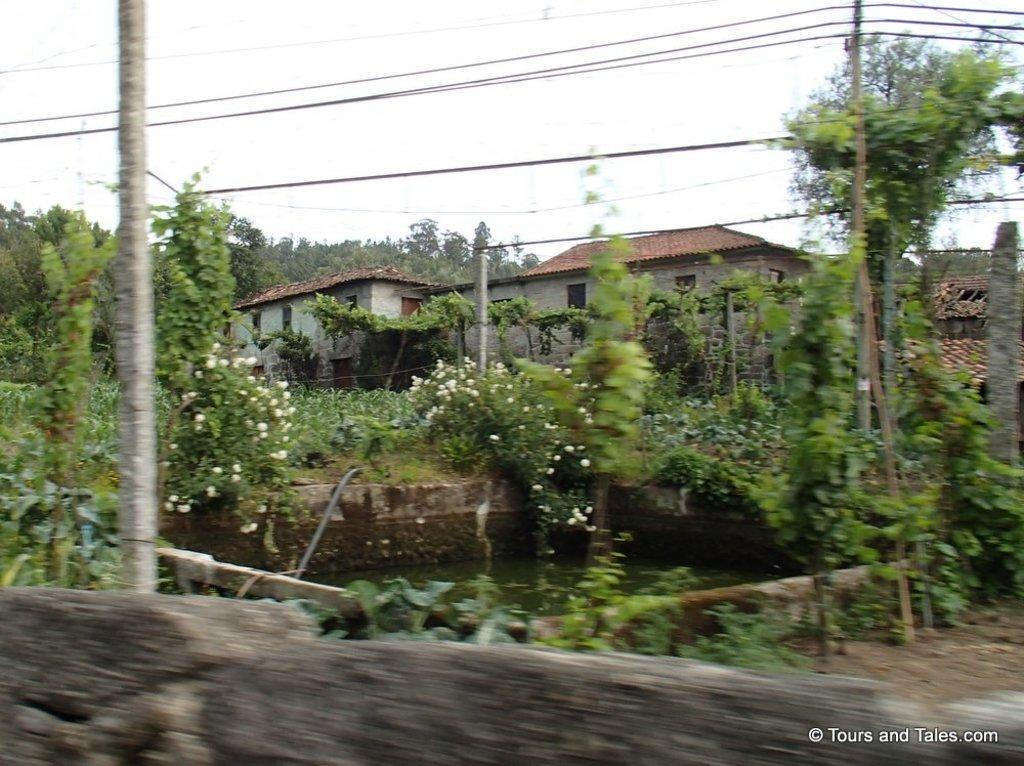What type of structures can be seen in the image? There are houses in the image. What type of vegetation is present in the image? There are plants, flowers, and trees in the image. What natural element is visible in the image? Water is visible in the image. What man-made structures are present in the image? There are poles and a wall in the image. What else can be seen in the image? There are wires and the sky visible in the background of the image. What time of day is it during the dinner in the image? There is no dinner present in the image, so it is not possible to determine the time of day. How many hours does it take for the flowers to smash in the image? There is no indication that the flowers are smashing or that any action is taking place in the image. 